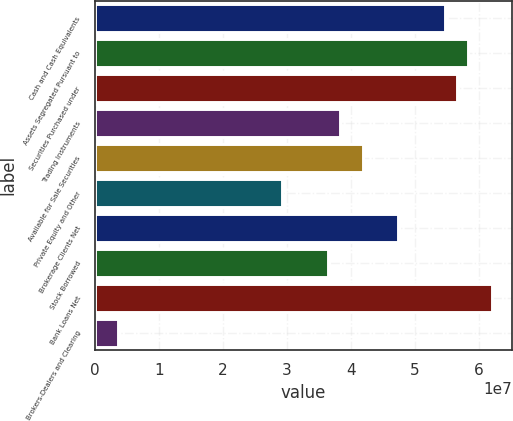<chart> <loc_0><loc_0><loc_500><loc_500><bar_chart><fcel>Cash and Cash Equivalents<fcel>Assets Segregated Pursuant to<fcel>Securities Purchased under<fcel>Trading Instruments<fcel>Available for Sale Securities<fcel>Private Equity and Other<fcel>Brokerage Clients Net<fcel>Stock Borrowed<fcel>Bank Loans Net<fcel>Brokers-Dealers and Clearing<nl><fcel>5.46777e+07<fcel>5.83228e+07<fcel>5.65003e+07<fcel>3.82748e+07<fcel>4.19199e+07<fcel>2.9162e+07<fcel>4.73875e+07<fcel>3.64522e+07<fcel>6.19679e+07<fcel>3.64633e+06<nl></chart> 